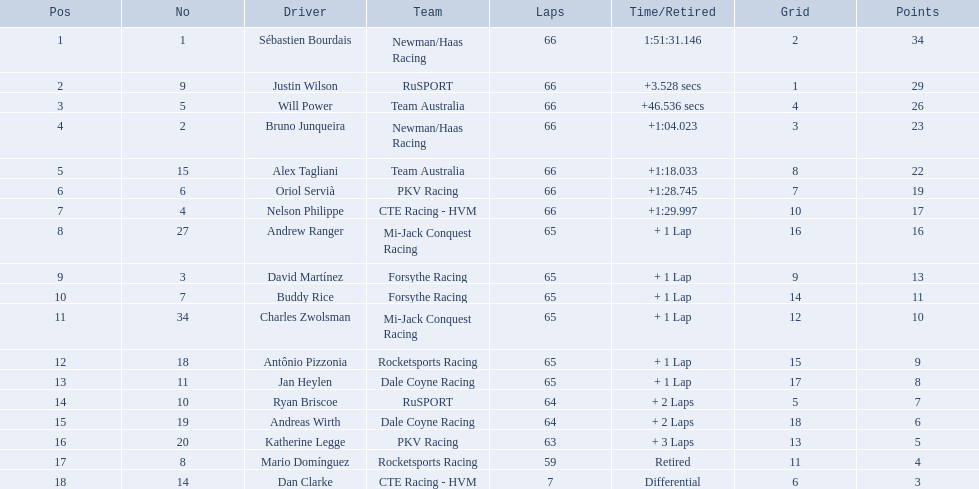Who reached 29+ points? Sébastien Bourdais, Justin Wilson. Who surpassed that? Sébastien Bourdais. What amount of points did the top finisher get? 34. What number of points did the bottom finisher get? 3. Who was the recipient of the points for the last position? Dan Clarke. What are the racers' digits? 1, 9, 5, 2, 15, 6, 4, 27, 3, 7, 34, 18, 11, 10, 19, 20, 8, 14. Are there any whose digit corresponds to their rank? Sébastien Bourdais, Oriol Servià. Of those two, who holds the top rank? Sébastien Bourdais. 